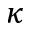<formula> <loc_0><loc_0><loc_500><loc_500>\kappa</formula> 